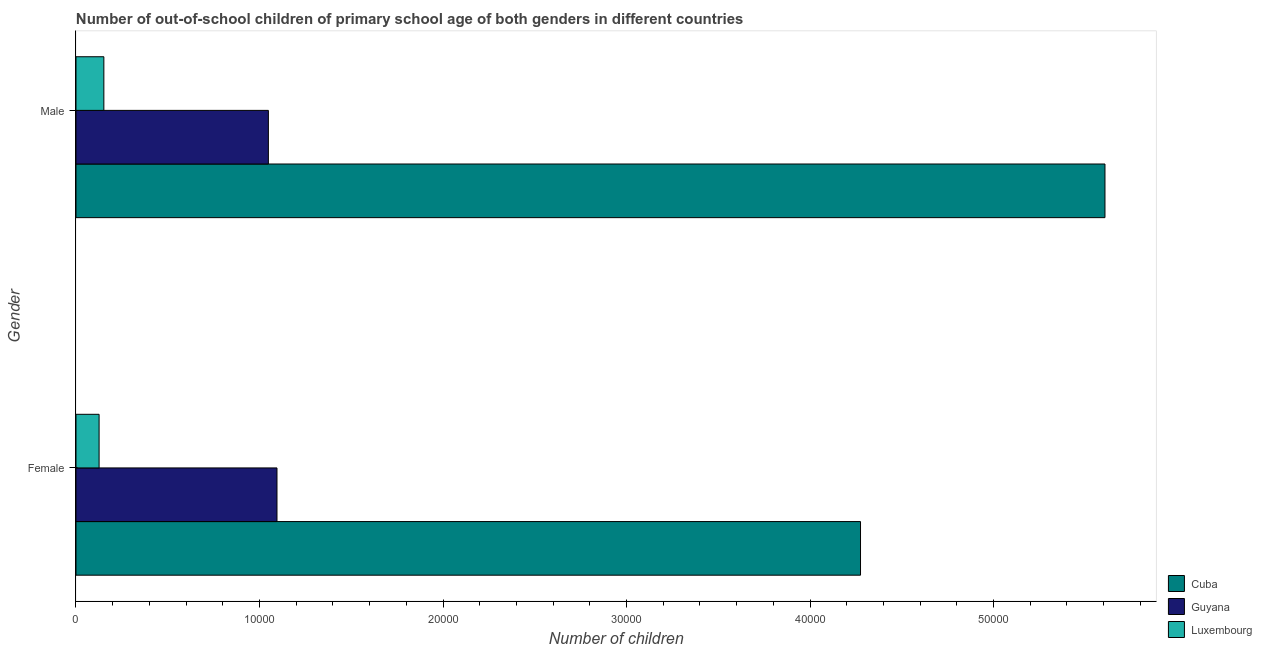How many groups of bars are there?
Your answer should be compact. 2. Are the number of bars per tick equal to the number of legend labels?
Provide a short and direct response. Yes. Are the number of bars on each tick of the Y-axis equal?
Your response must be concise. Yes. What is the label of the 1st group of bars from the top?
Ensure brevity in your answer.  Male. What is the number of female out-of-school students in Guyana?
Provide a short and direct response. 1.10e+04. Across all countries, what is the maximum number of female out-of-school students?
Give a very brief answer. 4.28e+04. Across all countries, what is the minimum number of female out-of-school students?
Your answer should be compact. 1259. In which country was the number of female out-of-school students maximum?
Give a very brief answer. Cuba. In which country was the number of male out-of-school students minimum?
Provide a short and direct response. Luxembourg. What is the total number of male out-of-school students in the graph?
Provide a succinct answer. 6.81e+04. What is the difference between the number of male out-of-school students in Guyana and that in Cuba?
Ensure brevity in your answer.  -4.56e+04. What is the difference between the number of male out-of-school students in Luxembourg and the number of female out-of-school students in Guyana?
Provide a succinct answer. -9434. What is the average number of male out-of-school students per country?
Provide a short and direct response. 2.27e+04. What is the difference between the number of female out-of-school students and number of male out-of-school students in Guyana?
Your response must be concise. 469. What is the ratio of the number of male out-of-school students in Guyana to that in Cuba?
Make the answer very short. 0.19. In how many countries, is the number of female out-of-school students greater than the average number of female out-of-school students taken over all countries?
Provide a short and direct response. 1. What does the 2nd bar from the top in Male represents?
Your response must be concise. Guyana. What does the 3rd bar from the bottom in Female represents?
Your response must be concise. Luxembourg. How many countries are there in the graph?
Keep it short and to the point. 3. What is the difference between two consecutive major ticks on the X-axis?
Provide a short and direct response. 10000. Does the graph contain any zero values?
Ensure brevity in your answer.  No. Does the graph contain grids?
Your answer should be compact. No. Where does the legend appear in the graph?
Your answer should be very brief. Bottom right. How many legend labels are there?
Provide a short and direct response. 3. How are the legend labels stacked?
Keep it short and to the point. Vertical. What is the title of the graph?
Provide a succinct answer. Number of out-of-school children of primary school age of both genders in different countries. Does "Pacific island small states" appear as one of the legend labels in the graph?
Keep it short and to the point. No. What is the label or title of the X-axis?
Make the answer very short. Number of children. What is the label or title of the Y-axis?
Keep it short and to the point. Gender. What is the Number of children of Cuba in Female?
Your answer should be compact. 4.28e+04. What is the Number of children of Guyana in Female?
Offer a very short reply. 1.10e+04. What is the Number of children of Luxembourg in Female?
Give a very brief answer. 1259. What is the Number of children of Cuba in Male?
Make the answer very short. 5.61e+04. What is the Number of children in Guyana in Male?
Ensure brevity in your answer.  1.05e+04. What is the Number of children of Luxembourg in Male?
Provide a succinct answer. 1519. Across all Gender, what is the maximum Number of children of Cuba?
Offer a terse response. 5.61e+04. Across all Gender, what is the maximum Number of children in Guyana?
Your answer should be very brief. 1.10e+04. Across all Gender, what is the maximum Number of children of Luxembourg?
Keep it short and to the point. 1519. Across all Gender, what is the minimum Number of children in Cuba?
Offer a terse response. 4.28e+04. Across all Gender, what is the minimum Number of children in Guyana?
Offer a terse response. 1.05e+04. Across all Gender, what is the minimum Number of children in Luxembourg?
Keep it short and to the point. 1259. What is the total Number of children in Cuba in the graph?
Offer a terse response. 9.88e+04. What is the total Number of children of Guyana in the graph?
Make the answer very short. 2.14e+04. What is the total Number of children of Luxembourg in the graph?
Provide a succinct answer. 2778. What is the difference between the Number of children of Cuba in Female and that in Male?
Offer a terse response. -1.33e+04. What is the difference between the Number of children in Guyana in Female and that in Male?
Your response must be concise. 469. What is the difference between the Number of children in Luxembourg in Female and that in Male?
Keep it short and to the point. -260. What is the difference between the Number of children of Cuba in Female and the Number of children of Guyana in Male?
Give a very brief answer. 3.23e+04. What is the difference between the Number of children in Cuba in Female and the Number of children in Luxembourg in Male?
Keep it short and to the point. 4.12e+04. What is the difference between the Number of children in Guyana in Female and the Number of children in Luxembourg in Male?
Make the answer very short. 9434. What is the average Number of children of Cuba per Gender?
Keep it short and to the point. 4.94e+04. What is the average Number of children of Guyana per Gender?
Provide a succinct answer. 1.07e+04. What is the average Number of children in Luxembourg per Gender?
Give a very brief answer. 1389. What is the difference between the Number of children of Cuba and Number of children of Guyana in Female?
Make the answer very short. 3.18e+04. What is the difference between the Number of children in Cuba and Number of children in Luxembourg in Female?
Keep it short and to the point. 4.15e+04. What is the difference between the Number of children of Guyana and Number of children of Luxembourg in Female?
Offer a very short reply. 9694. What is the difference between the Number of children in Cuba and Number of children in Guyana in Male?
Ensure brevity in your answer.  4.56e+04. What is the difference between the Number of children in Cuba and Number of children in Luxembourg in Male?
Your response must be concise. 5.46e+04. What is the difference between the Number of children in Guyana and Number of children in Luxembourg in Male?
Offer a terse response. 8965. What is the ratio of the Number of children in Cuba in Female to that in Male?
Your answer should be compact. 0.76. What is the ratio of the Number of children of Guyana in Female to that in Male?
Offer a terse response. 1.04. What is the ratio of the Number of children in Luxembourg in Female to that in Male?
Provide a short and direct response. 0.83. What is the difference between the highest and the second highest Number of children of Cuba?
Ensure brevity in your answer.  1.33e+04. What is the difference between the highest and the second highest Number of children of Guyana?
Provide a short and direct response. 469. What is the difference between the highest and the second highest Number of children in Luxembourg?
Offer a terse response. 260. What is the difference between the highest and the lowest Number of children of Cuba?
Your answer should be compact. 1.33e+04. What is the difference between the highest and the lowest Number of children of Guyana?
Provide a short and direct response. 469. What is the difference between the highest and the lowest Number of children of Luxembourg?
Offer a terse response. 260. 